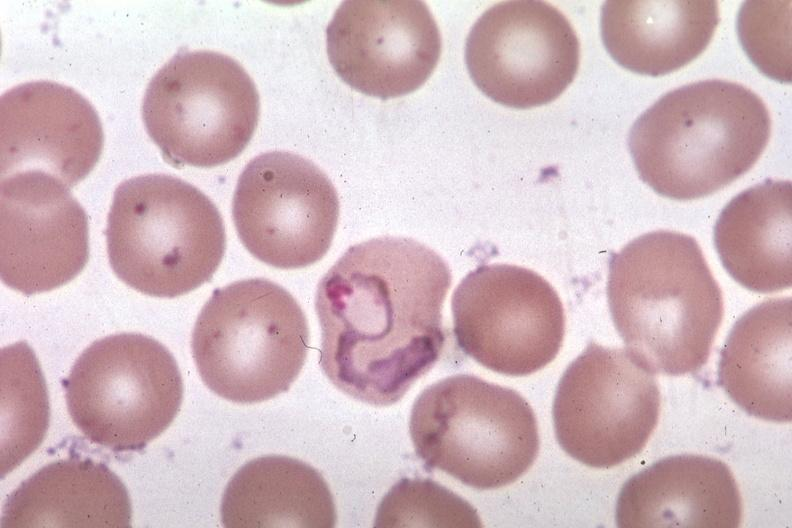s hematologic present?
Answer the question using a single word or phrase. Yes 